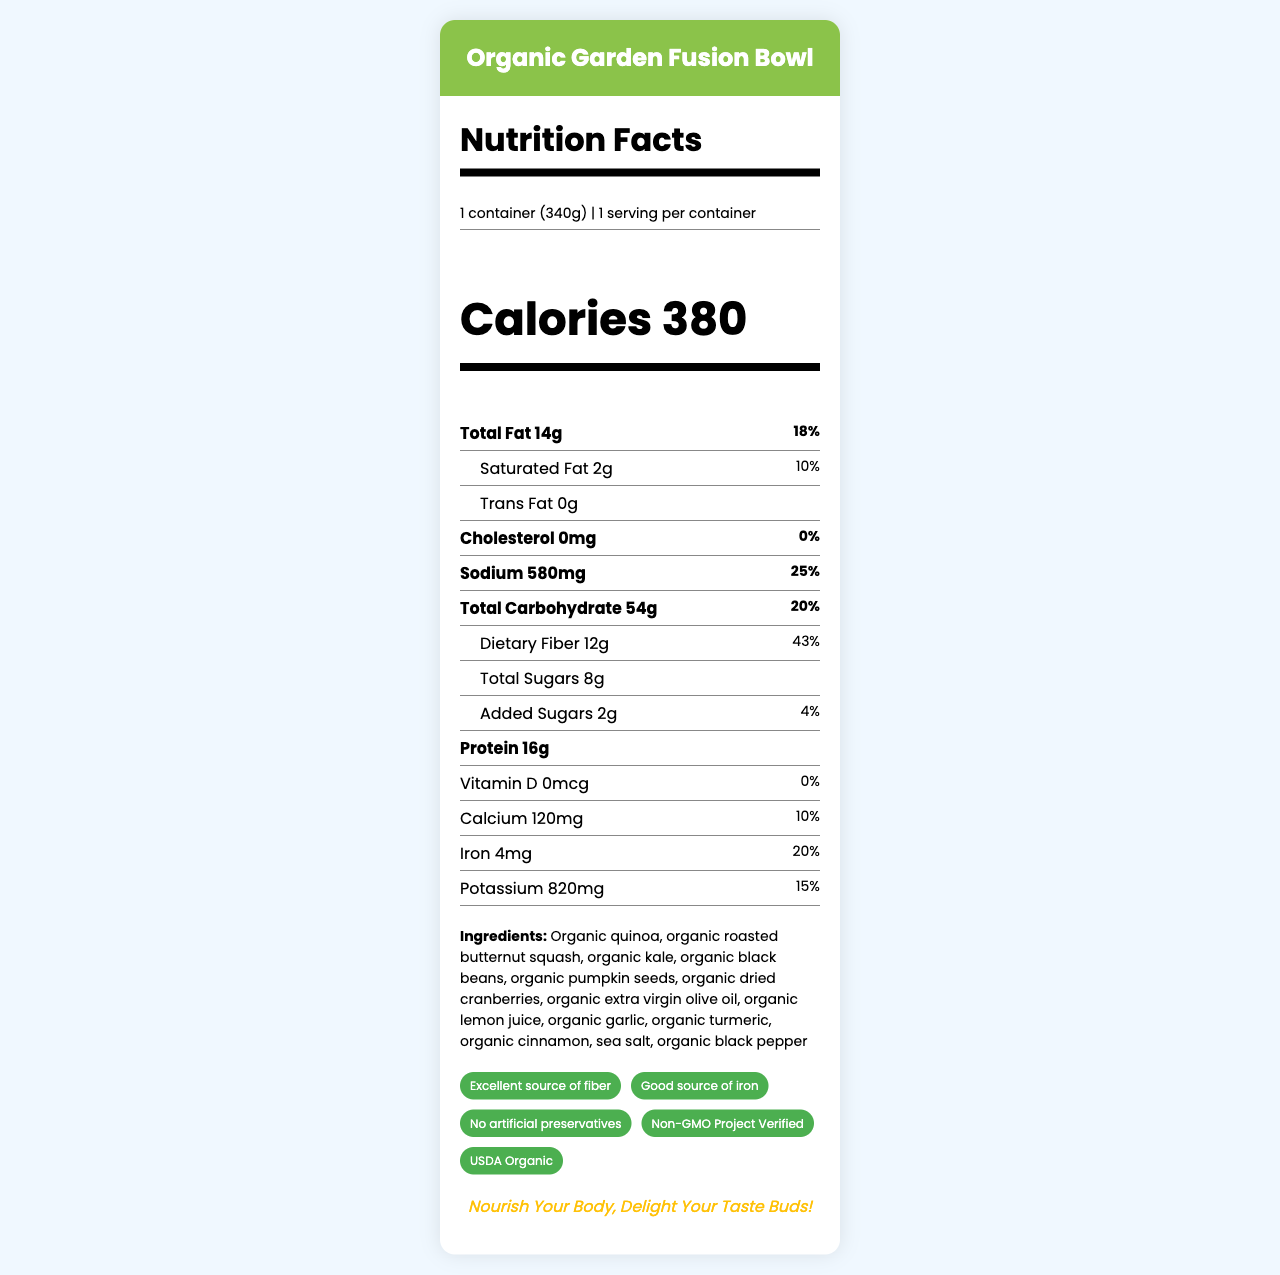what is the serving size of the Organic Garden Fusion Bowl? The serving size is clearly listed in the top part of the nutrition facts as "1 container (340g)".
Answer: 1 container (340g) How many calories are there per serving? The calories per serving are listed prominently in large text: "Calories 380".
Answer: 380 How much dietary fiber does the Organic Garden Fusion Bowl contain? The dietary fiber amount is listed in the nutrient section as "Dietary Fiber 12g".
Answer: 12g What is the daily value percentage for total fat? The daily value percentage for total fat is listed as "18%" beside the amount of fat in grams.
Answer: 18% List three main ingredients of the Organic Garden Fusion Bowl. The ingredients section lists the ingredients, and the first three are organic quinoa, organic roasted butternut squash, and organic kale.
Answer: Organic quinoa, organic roasted butternut squash, organic kale Which of the following is a health claim made on the label?
A. High in Vitamin C
B. Excellent source of protein
C. Non-GMO Project Verified
D. Contains gluten The health claims section lists "Non-GMO Project Verified" among others, but not the other options.
Answer: C What is the sodium content in the Organic Garden Fusion Bowl? A. 120mg B. 320mg C. 580mg D. 820mg The sodium content is listed in the nutrition facts as "580mg".
Answer: C Does the product contain any added sugars? The added sugars are listed as "Added Sugars 2g".
Answer: Yes Is this product heart-healthy based on the label? One of the icons in the creative elements section is labeled "heart_healthy".
Answer: Yes Are there any allergens listed in the allergen information? The allergen information states "Contains: None".
Answer: No Summarize the main idea of the document. The document provides a comprehensive description of the Organic Garden Fusion Bowl, detailing its nutritional content, ingredients, and various health claims. It also highlights unique visual and interactive elements intended to enhance customer engagement.
Answer: The document is a nutrition facts label for the Organic Garden Fusion Bowl, an organic, plant-based frozen meal. It provides detailed nutritional information, ingredient lists, and health claims. The label includes creative design elements to attract customers, such as a vibrant color scheme, interactive features, and a QR code. How much iron does the Organic Garden Fusion Bowl provide? The amount of iron is listed in the nutrition facts as "Iron 4mg".
Answer: 4mg Is the amount of Vitamin D in the product significant? The nutrition facts state "Vitamin D 0mcg" with a daily value of "0%", indicating it is not significant.
Answer: No Can you determine the manufacturing date of the product from the label? The label does not provide any information regarding the manufacturing date.
Answer: Cannot be determined What is the unique feature highlighted on the label? The unique feature section mentions a "QR code linking to recipe variations and sustainability practices".
Answer: QR code linking to recipe variations and sustainability practices What is the slogan displayed on the label? The slogan is shown at the bottom of the label in italic text.
Answer: "Nourish Your Body, Delight Your Taste Buds!" 